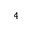Convert formula to latex. <formula><loc_0><loc_0><loc_500><loc_500>^ { 4 }</formula> 